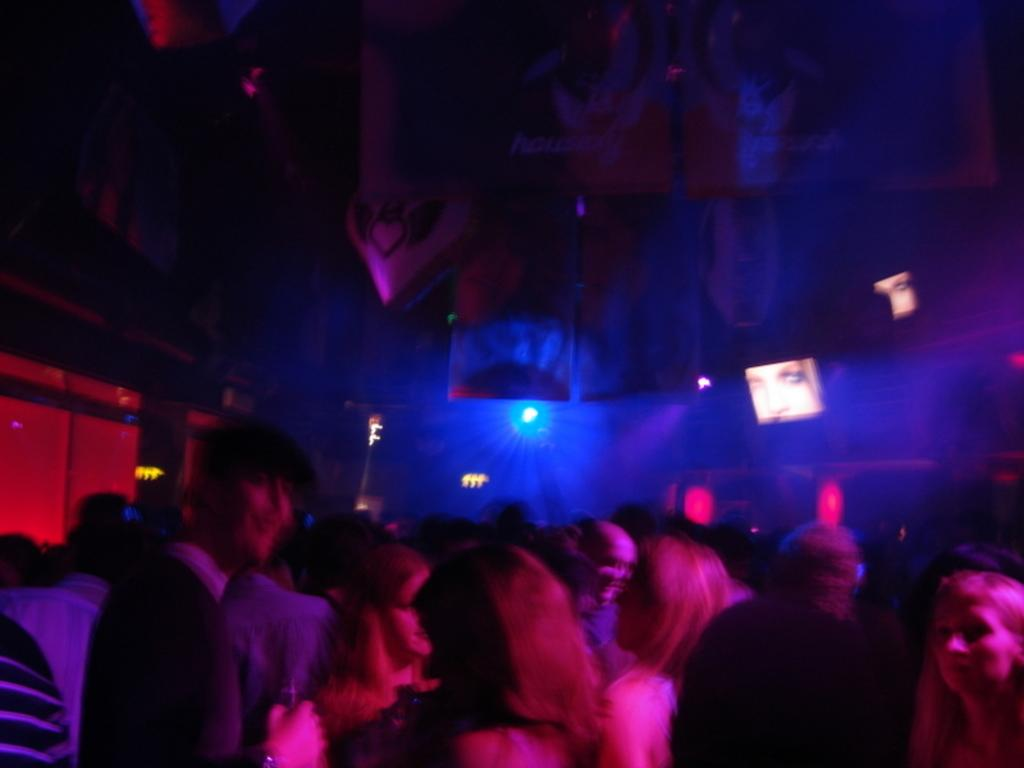What can be seen in the image that adds visual interest? There are decorations in the image. Who or what is located at the bottom of the image? There are people at the bottom of the image. What is the source of light in the image? There is a light in the middle of the image. Can you tell me how many eggs are being used as decorations in the image? There is no mention of eggs in the image, so it is not possible to determine if they are being used as decorations. What type of pets are present in the image? There is no mention of pets in the image. 